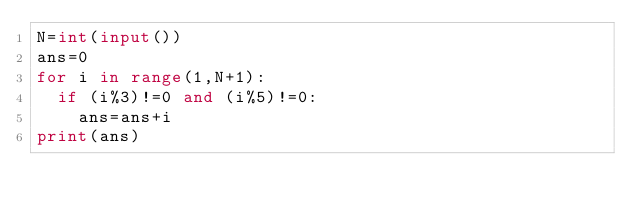Convert code to text. <code><loc_0><loc_0><loc_500><loc_500><_Python_>N=int(input())
ans=0
for i in range(1,N+1):
  if (i%3)!=0 and (i%5)!=0:
    ans=ans+i
print(ans)
</code> 